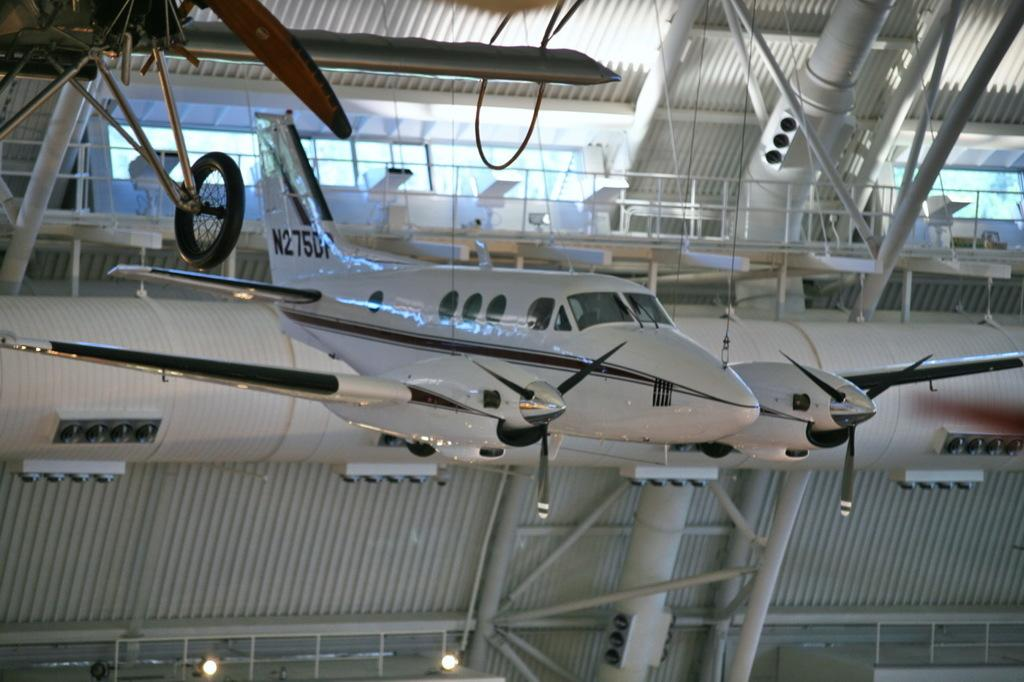What type of vehicles can be seen in the image? There are planes in the image. What type of structure is present in the image? There is a shed in the image. What can be used to provide illumination in the image? There are lights in the image. What type of long, thin bars can be seen in the image? There are rods in the image. What can be used for support or safety in the image? There is railing in the image. What can be used to allow light or air into a structure in the image? There are windows in the image. What general term can be used to describe the various items visible in the image? There are objects in the image. What type of shirt is being worn by the spot in the image? There is no shirt or spot present in the image. How many quarters can be seen on the railing in the image? There are no quarters present in the image. 